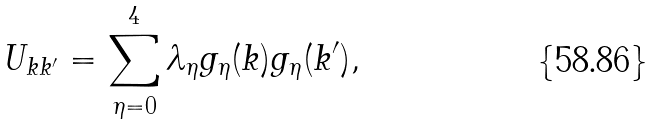Convert formula to latex. <formula><loc_0><loc_0><loc_500><loc_500>U _ { k k ^ { \prime } } = \sum _ { \eta = 0 } ^ { 4 } \lambda _ { \eta } g _ { \eta } ( { k } ) g _ { \eta } ( { k ^ { \prime } } ) ,</formula> 